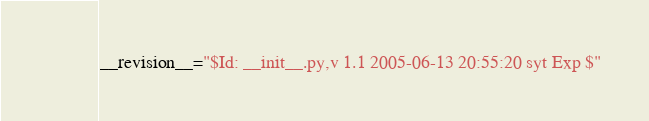<code> <loc_0><loc_0><loc_500><loc_500><_Python_>__revision__="$Id: __init__.py,v 1.1 2005-06-13 20:55:20 syt Exp $"
</code> 